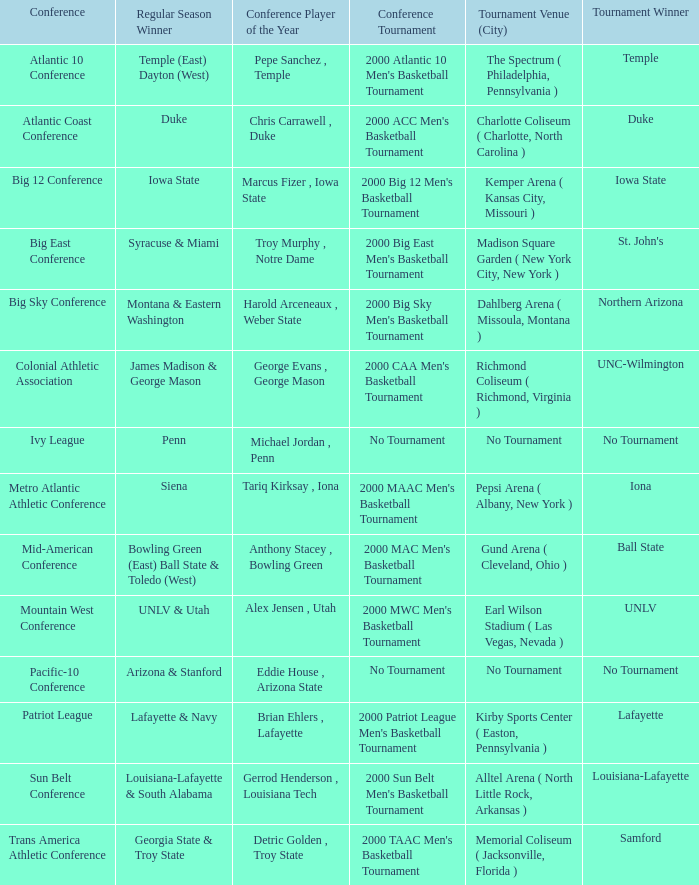Where did the ivy league conference competition take place? No Tournament. 